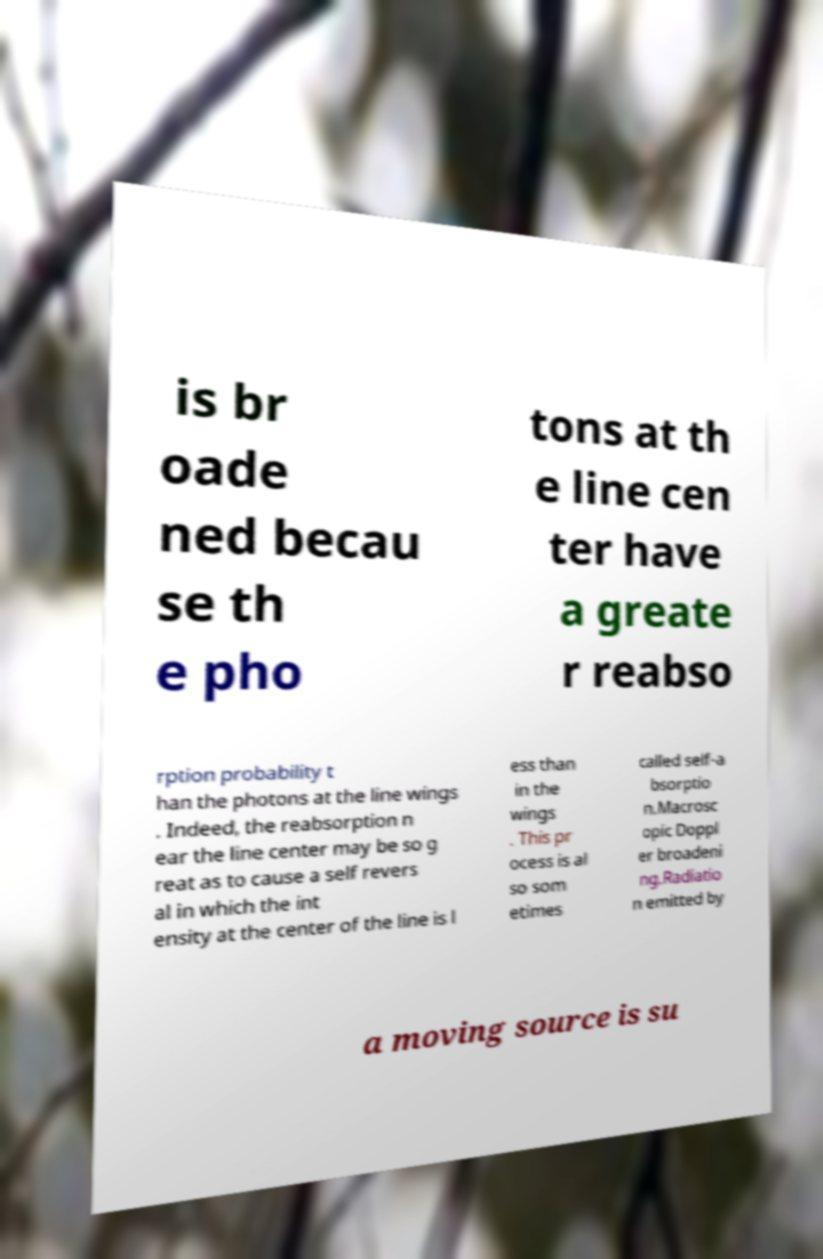For documentation purposes, I need the text within this image transcribed. Could you provide that? is br oade ned becau se th e pho tons at th e line cen ter have a greate r reabso rption probability t han the photons at the line wings . Indeed, the reabsorption n ear the line center may be so g reat as to cause a self revers al in which the int ensity at the center of the line is l ess than in the wings . This pr ocess is al so som etimes called self-a bsorptio n.Macrosc opic Doppl er broadeni ng.Radiatio n emitted by a moving source is su 